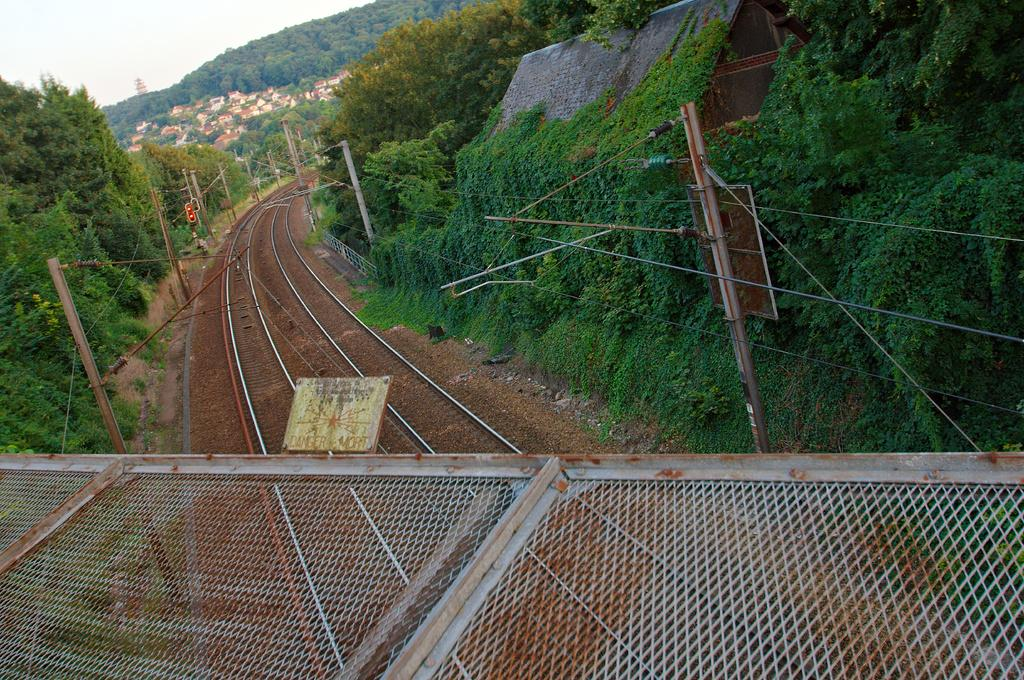What type of material is present in the image? There is mesh in the image. What can be seen on the ground in the image? There are tracks in the image. What is attached to the poles in the image? There are wires attached to the poles in the image. What is visible on top of the roof in the image? There is a roof top visible in the image. What type of vegetation is present in the image? There are trees in the image. What can be seen in the background of the image? In the background, there are trees, houses, and sky visible. What type of music can be heard playing in the background of the image? There is no music present in the image, as it is a visual representation and does not include sound. What is the hope level of the trees in the image? The image does not convey any information about the hope level of the trees, as it is a visual representation and does not include emotions or feelings. 